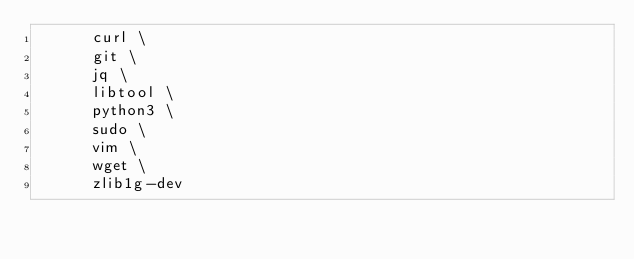<code> <loc_0><loc_0><loc_500><loc_500><_Dockerfile_>      curl \
      git \
      jq \
      libtool \
      python3 \
      sudo \
      vim \
      wget \
      zlib1g-dev</code> 